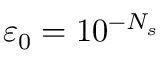<formula> <loc_0><loc_0><loc_500><loc_500>\varepsilon _ { 0 } = 1 0 ^ { - N _ { s } }</formula> 